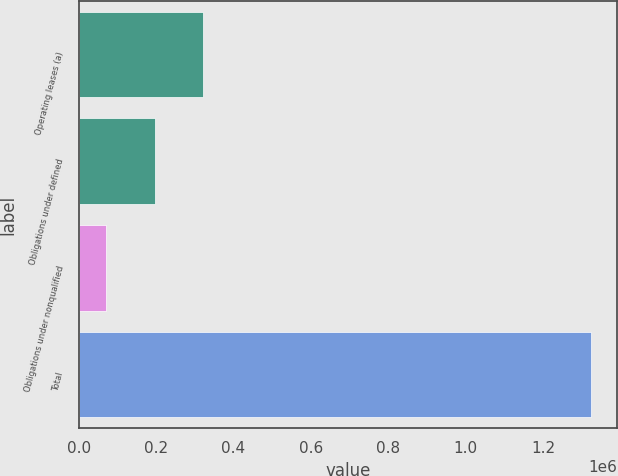Convert chart. <chart><loc_0><loc_0><loc_500><loc_500><bar_chart><fcel>Operating leases (a)<fcel>Obligations under defined<fcel>Obligations under nonqualified<fcel>Total<nl><fcel>321829<fcel>196598<fcel>71366<fcel>1.32368e+06<nl></chart> 